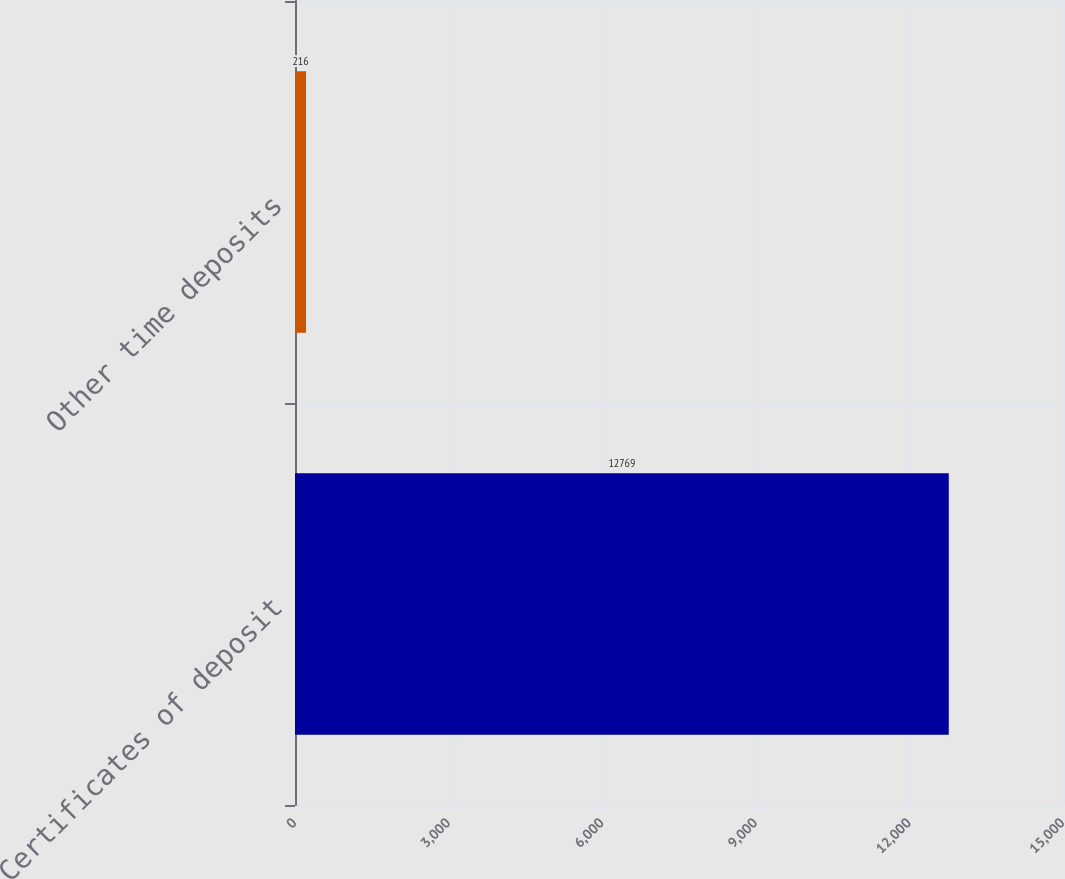Convert chart. <chart><loc_0><loc_0><loc_500><loc_500><bar_chart><fcel>Certificates of deposit<fcel>Other time deposits<nl><fcel>12769<fcel>216<nl></chart> 